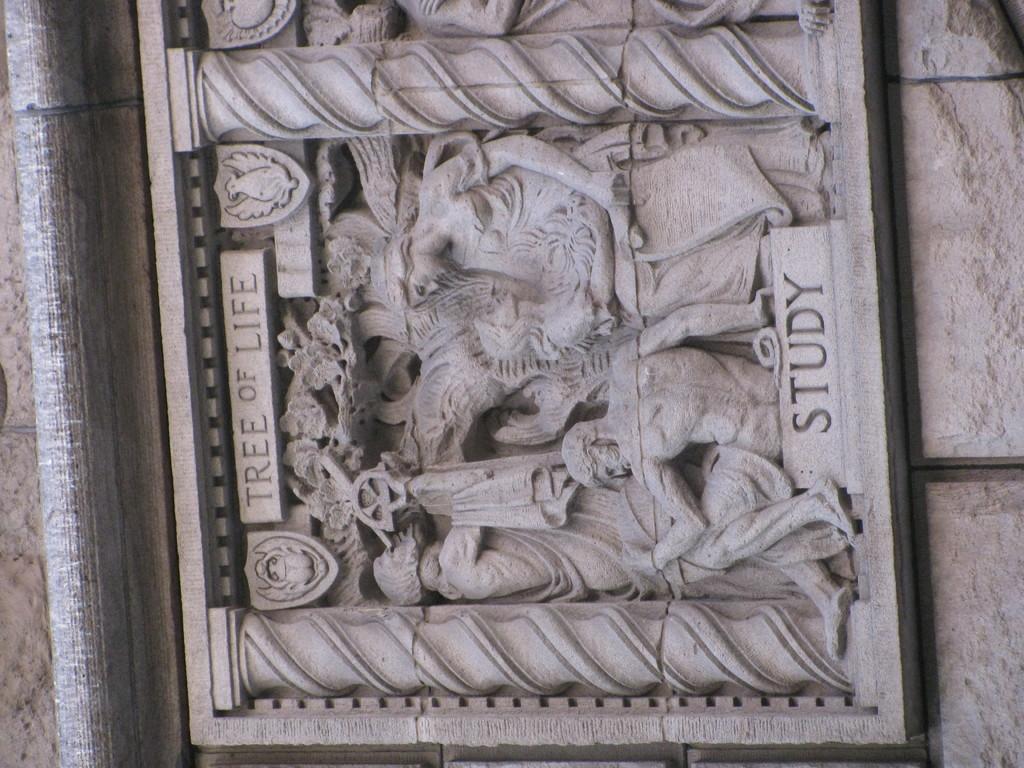Describe this image in one or two sentences. In this picture we can see a wall on the right side, there is a carved stone in the middle. 